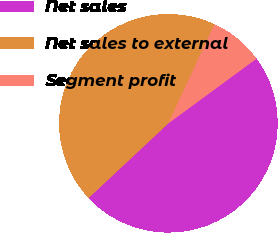Convert chart to OTSL. <chart><loc_0><loc_0><loc_500><loc_500><pie_chart><fcel>Net sales<fcel>Net sales to external<fcel>Segment profit<nl><fcel>48.1%<fcel>43.9%<fcel>7.99%<nl></chart> 